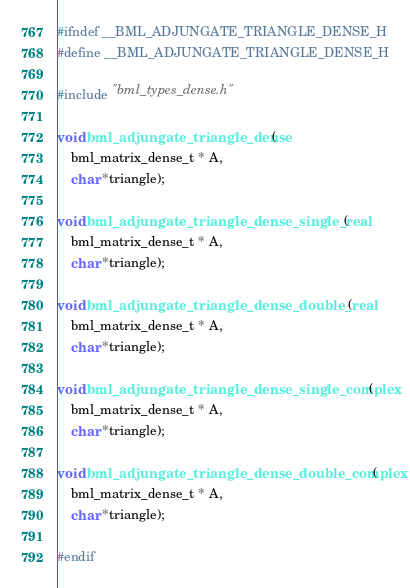Convert code to text. <code><loc_0><loc_0><loc_500><loc_500><_C_>#ifndef __BML_ADJUNGATE_TRIANGLE_DENSE_H
#define __BML_ADJUNGATE_TRIANGLE_DENSE_H

#include "bml_types_dense.h"

void bml_adjungate_triangle_dense(
    bml_matrix_dense_t * A,
    char *triangle);

void bml_adjungate_triangle_dense_single_real(
    bml_matrix_dense_t * A,
    char *triangle);

void bml_adjungate_triangle_dense_double_real(
    bml_matrix_dense_t * A,
    char *triangle);

void bml_adjungate_triangle_dense_single_complex(
    bml_matrix_dense_t * A,
    char *triangle);

void bml_adjungate_triangle_dense_double_complex(
    bml_matrix_dense_t * A,
    char *triangle);

#endif
</code> 